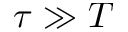<formula> <loc_0><loc_0><loc_500><loc_500>\tau \gg T</formula> 